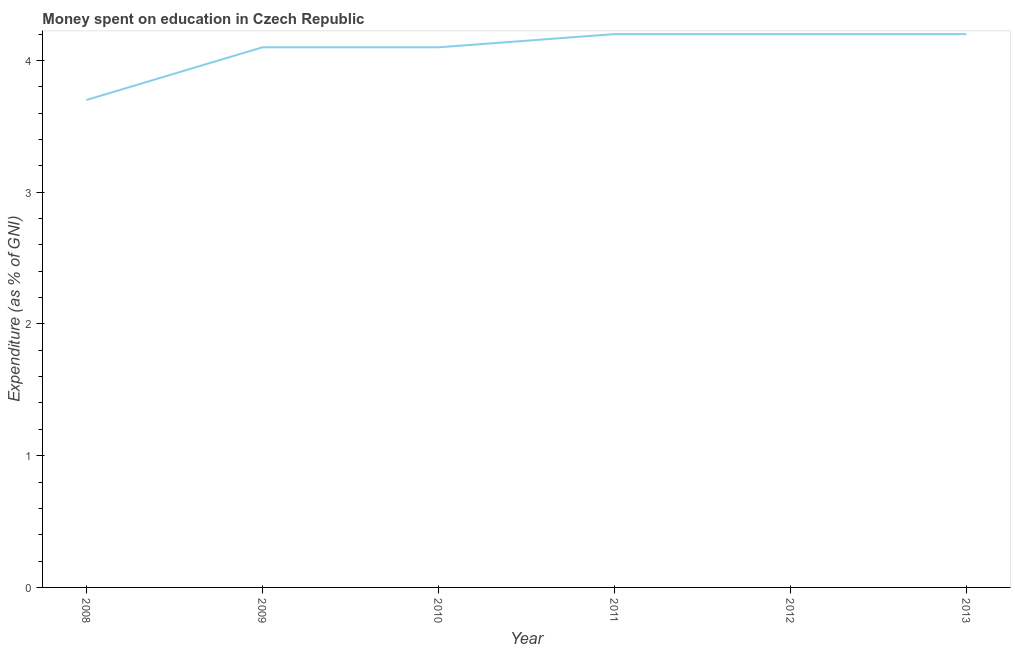Across all years, what is the maximum expenditure on education?
Your answer should be compact. 4.2. Across all years, what is the minimum expenditure on education?
Ensure brevity in your answer.  3.7. What is the sum of the expenditure on education?
Offer a very short reply. 24.5. What is the difference between the expenditure on education in 2010 and 2012?
Provide a short and direct response. -0.1. What is the average expenditure on education per year?
Make the answer very short. 4.08. What is the median expenditure on education?
Keep it short and to the point. 4.15. In how many years, is the expenditure on education greater than 0.6000000000000001 %?
Ensure brevity in your answer.  6. Do a majority of the years between 2012 and 2008 (inclusive) have expenditure on education greater than 3.2 %?
Offer a very short reply. Yes. What is the ratio of the expenditure on education in 2009 to that in 2012?
Your response must be concise. 0.98. Is the expenditure on education in 2008 less than that in 2011?
Your answer should be compact. Yes. Is the difference between the expenditure on education in 2008 and 2011 greater than the difference between any two years?
Offer a terse response. Yes. Does the expenditure on education monotonically increase over the years?
Your answer should be very brief. No. How many years are there in the graph?
Your response must be concise. 6. Does the graph contain any zero values?
Your answer should be very brief. No. Does the graph contain grids?
Give a very brief answer. No. What is the title of the graph?
Offer a terse response. Money spent on education in Czech Republic. What is the label or title of the Y-axis?
Give a very brief answer. Expenditure (as % of GNI). What is the Expenditure (as % of GNI) in 2008?
Your answer should be very brief. 3.7. What is the Expenditure (as % of GNI) of 2011?
Give a very brief answer. 4.2. What is the Expenditure (as % of GNI) in 2012?
Keep it short and to the point. 4.2. What is the difference between the Expenditure (as % of GNI) in 2008 and 2009?
Make the answer very short. -0.4. What is the difference between the Expenditure (as % of GNI) in 2008 and 2012?
Give a very brief answer. -0.5. What is the difference between the Expenditure (as % of GNI) in 2008 and 2013?
Make the answer very short. -0.5. What is the difference between the Expenditure (as % of GNI) in 2009 and 2010?
Offer a terse response. 0. What is the difference between the Expenditure (as % of GNI) in 2009 and 2013?
Keep it short and to the point. -0.1. What is the difference between the Expenditure (as % of GNI) in 2010 and 2012?
Your answer should be compact. -0.1. What is the difference between the Expenditure (as % of GNI) in 2011 and 2012?
Provide a short and direct response. 0. What is the difference between the Expenditure (as % of GNI) in 2011 and 2013?
Make the answer very short. 0. What is the ratio of the Expenditure (as % of GNI) in 2008 to that in 2009?
Offer a terse response. 0.9. What is the ratio of the Expenditure (as % of GNI) in 2008 to that in 2010?
Your response must be concise. 0.9. What is the ratio of the Expenditure (as % of GNI) in 2008 to that in 2011?
Offer a terse response. 0.88. What is the ratio of the Expenditure (as % of GNI) in 2008 to that in 2012?
Keep it short and to the point. 0.88. What is the ratio of the Expenditure (as % of GNI) in 2008 to that in 2013?
Offer a terse response. 0.88. What is the ratio of the Expenditure (as % of GNI) in 2009 to that in 2011?
Your answer should be very brief. 0.98. What is the ratio of the Expenditure (as % of GNI) in 2009 to that in 2012?
Keep it short and to the point. 0.98. What is the ratio of the Expenditure (as % of GNI) in 2009 to that in 2013?
Your response must be concise. 0.98. What is the ratio of the Expenditure (as % of GNI) in 2010 to that in 2011?
Offer a terse response. 0.98. What is the ratio of the Expenditure (as % of GNI) in 2011 to that in 2012?
Your response must be concise. 1. 